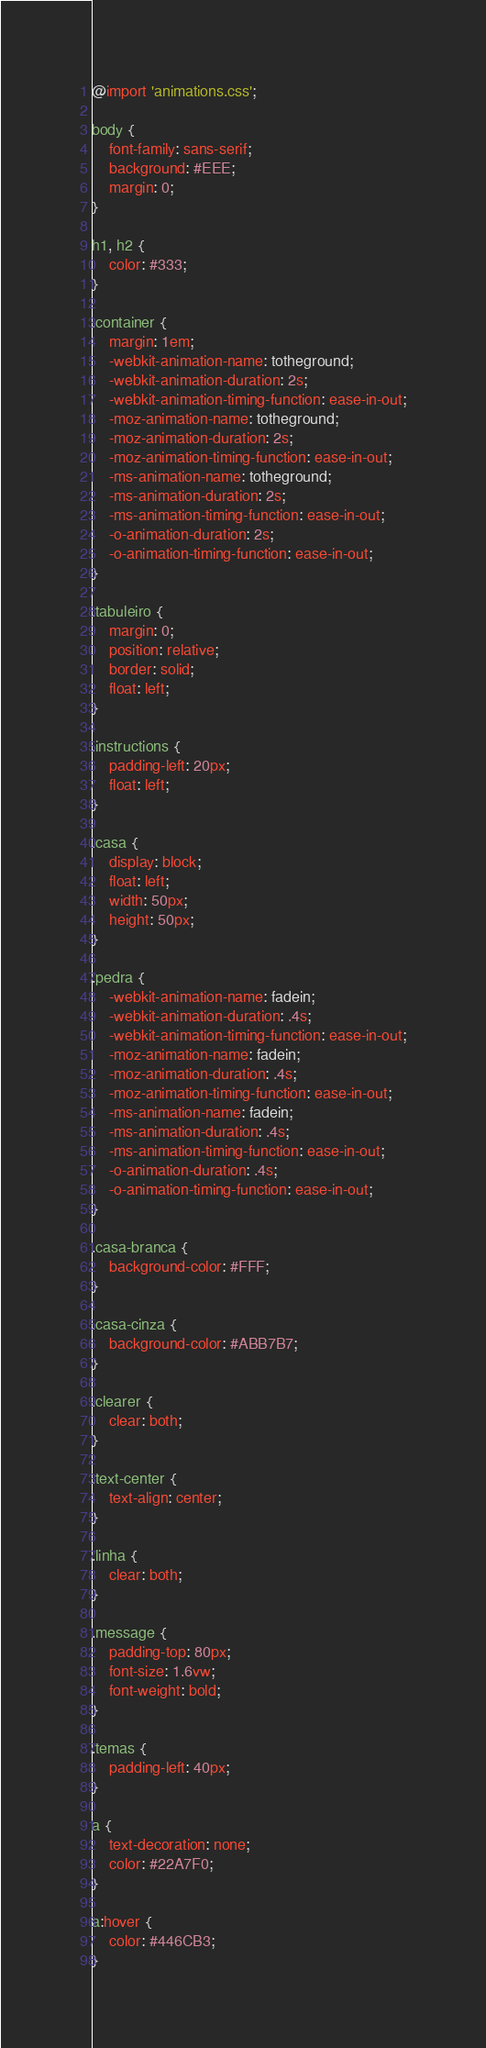<code> <loc_0><loc_0><loc_500><loc_500><_CSS_>@import 'animations.css';

body {
    font-family: sans-serif;
    background: #EEE;
    margin: 0;
}

h1, h2 {
    color: #333;
}

.container {
    margin: 1em;
    -webkit-animation-name: totheground;
    -webkit-animation-duration: 2s;
    -webkit-animation-timing-function: ease-in-out;
    -moz-animation-name: totheground;
    -moz-animation-duration: 2s;
    -moz-animation-timing-function: ease-in-out;
    -ms-animation-name: totheground;
    -ms-animation-duration: 2s;
    -ms-animation-timing-function: ease-in-out;
    -o-animation-duration: 2s;
    -o-animation-timing-function: ease-in-out;
}

.tabuleiro {
    margin: 0;
    position: relative;
    border: solid;
    float: left;
}

.instructions {
    padding-left: 20px;
    float: left;
}

.casa {
    display: block;
    float: left;
    width: 50px;
    height: 50px;
}

.pedra {
    -webkit-animation-name: fadein;
    -webkit-animation-duration: .4s;
    -webkit-animation-timing-function: ease-in-out;
    -moz-animation-name: fadein;
    -moz-animation-duration: .4s;
    -moz-animation-timing-function: ease-in-out;
    -ms-animation-name: fadein;
    -ms-animation-duration: .4s;
    -ms-animation-timing-function: ease-in-out;
    -o-animation-duration: .4s;
    -o-animation-timing-function: ease-in-out;
}

.casa-branca {
    background-color: #FFF;
}

.casa-cinza {
    background-color: #ABB7B7;
}

.clearer {
    clear: both;
}

.text-center {
    text-align: center;
}

.linha {
    clear: both;
}
 
.message {
    padding-top: 80px;
    font-size: 1.6vw;
    font-weight: bold;
}

.temas {
    padding-left: 40px;
}

a {
    text-decoration: none;
    color: #22A7F0;
}

a:hover {
    color: #446CB3;
}
</code> 